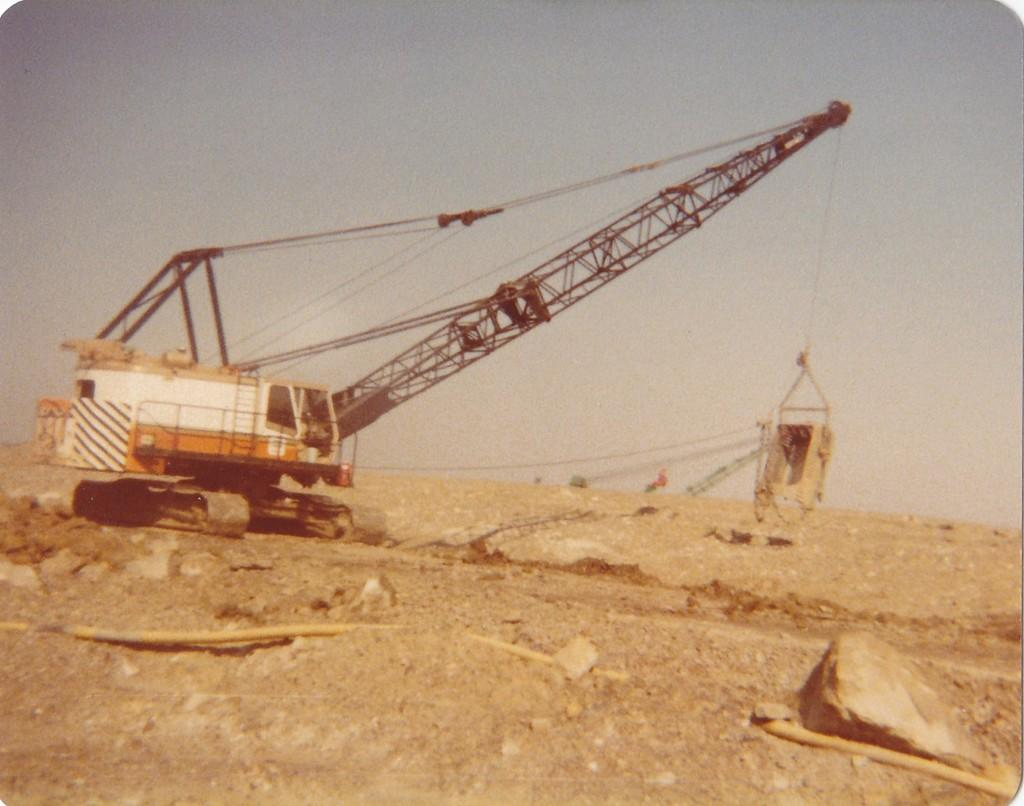What type of machinery is present on the ground in the image? There is a crane on the ground in the image. What other objects can be seen in the image? There are stones and wires visible in the image. What is visible in the background of the image? The sky is visible in the background of the image. Reasoning: Let's think step by following the guidelines to produce the conversation. We start by identifying the main subject in the image, which is the crane on the ground. Then, we expand the conversation to include other objects that are also visible, such as stones and wires. Each question is designed to elicit a specific detail about the image that is known from the provided facts. We avoid yes/no questions and ensure that the language is simple and clear. Absurd Question/Answer: What type of thrill can be experienced by the crane in the image? There is no indication of a thrill or any emotional state in the image; it is a static representation of a crane, stones, and wires. What type of drain can be seen in the image? There is no drain present in the image; it features a crane, stones, and wires. --- Facts: 1. There is a person sitting on a bench in the image. 2. The person is reading a book. 3. There is a tree behind the bench. 4. The sky is visible in the background of the image. Absurd Topics: dance, fire, parrot Conversation: What is the person in the image doing? The person in the image is sitting on a bench and reading a book. What can be seen behind the bench? There is a tree behind the bench. What is visible in the background of the image? The sky is visible in the background of the image. Reasoning: Let's think step by following the guidelines to produce the conversation. We start by identifying the main subject in the image, which is the person sitting on a bench. Then, we describe the person's activity, which is reading a book. Next, we observe the objects in the background, such as the tree and the sky. Each question is designed to elicit a specific detail about the image that is known from the provided facts. We avoid yes/no questions and ensure that the language 